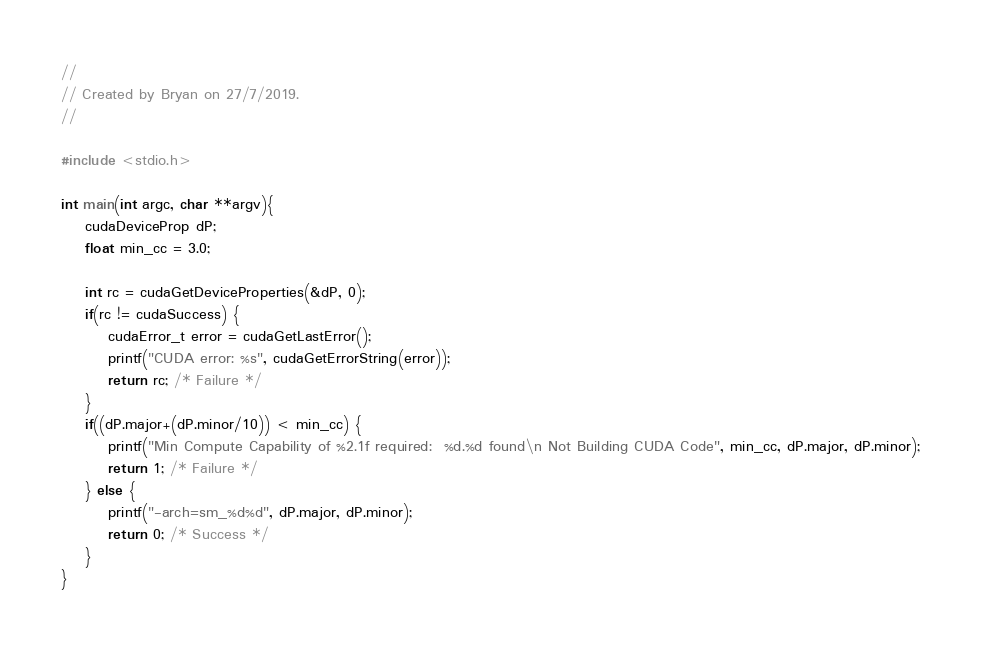Convert code to text. <code><loc_0><loc_0><loc_500><loc_500><_Cuda_>//
// Created by Bryan on 27/7/2019.
//

#include <stdio.h>

int main(int argc, char **argv){
    cudaDeviceProp dP;
    float min_cc = 3.0;

    int rc = cudaGetDeviceProperties(&dP, 0);
    if(rc != cudaSuccess) {
        cudaError_t error = cudaGetLastError();
        printf("CUDA error: %s", cudaGetErrorString(error));
        return rc; /* Failure */
    }
    if((dP.major+(dP.minor/10)) < min_cc) {
        printf("Min Compute Capability of %2.1f required:  %d.%d found\n Not Building CUDA Code", min_cc, dP.major, dP.minor);
        return 1; /* Failure */
    } else {
        printf("-arch=sm_%d%d", dP.major, dP.minor);
        return 0; /* Success */
    }
}

</code> 